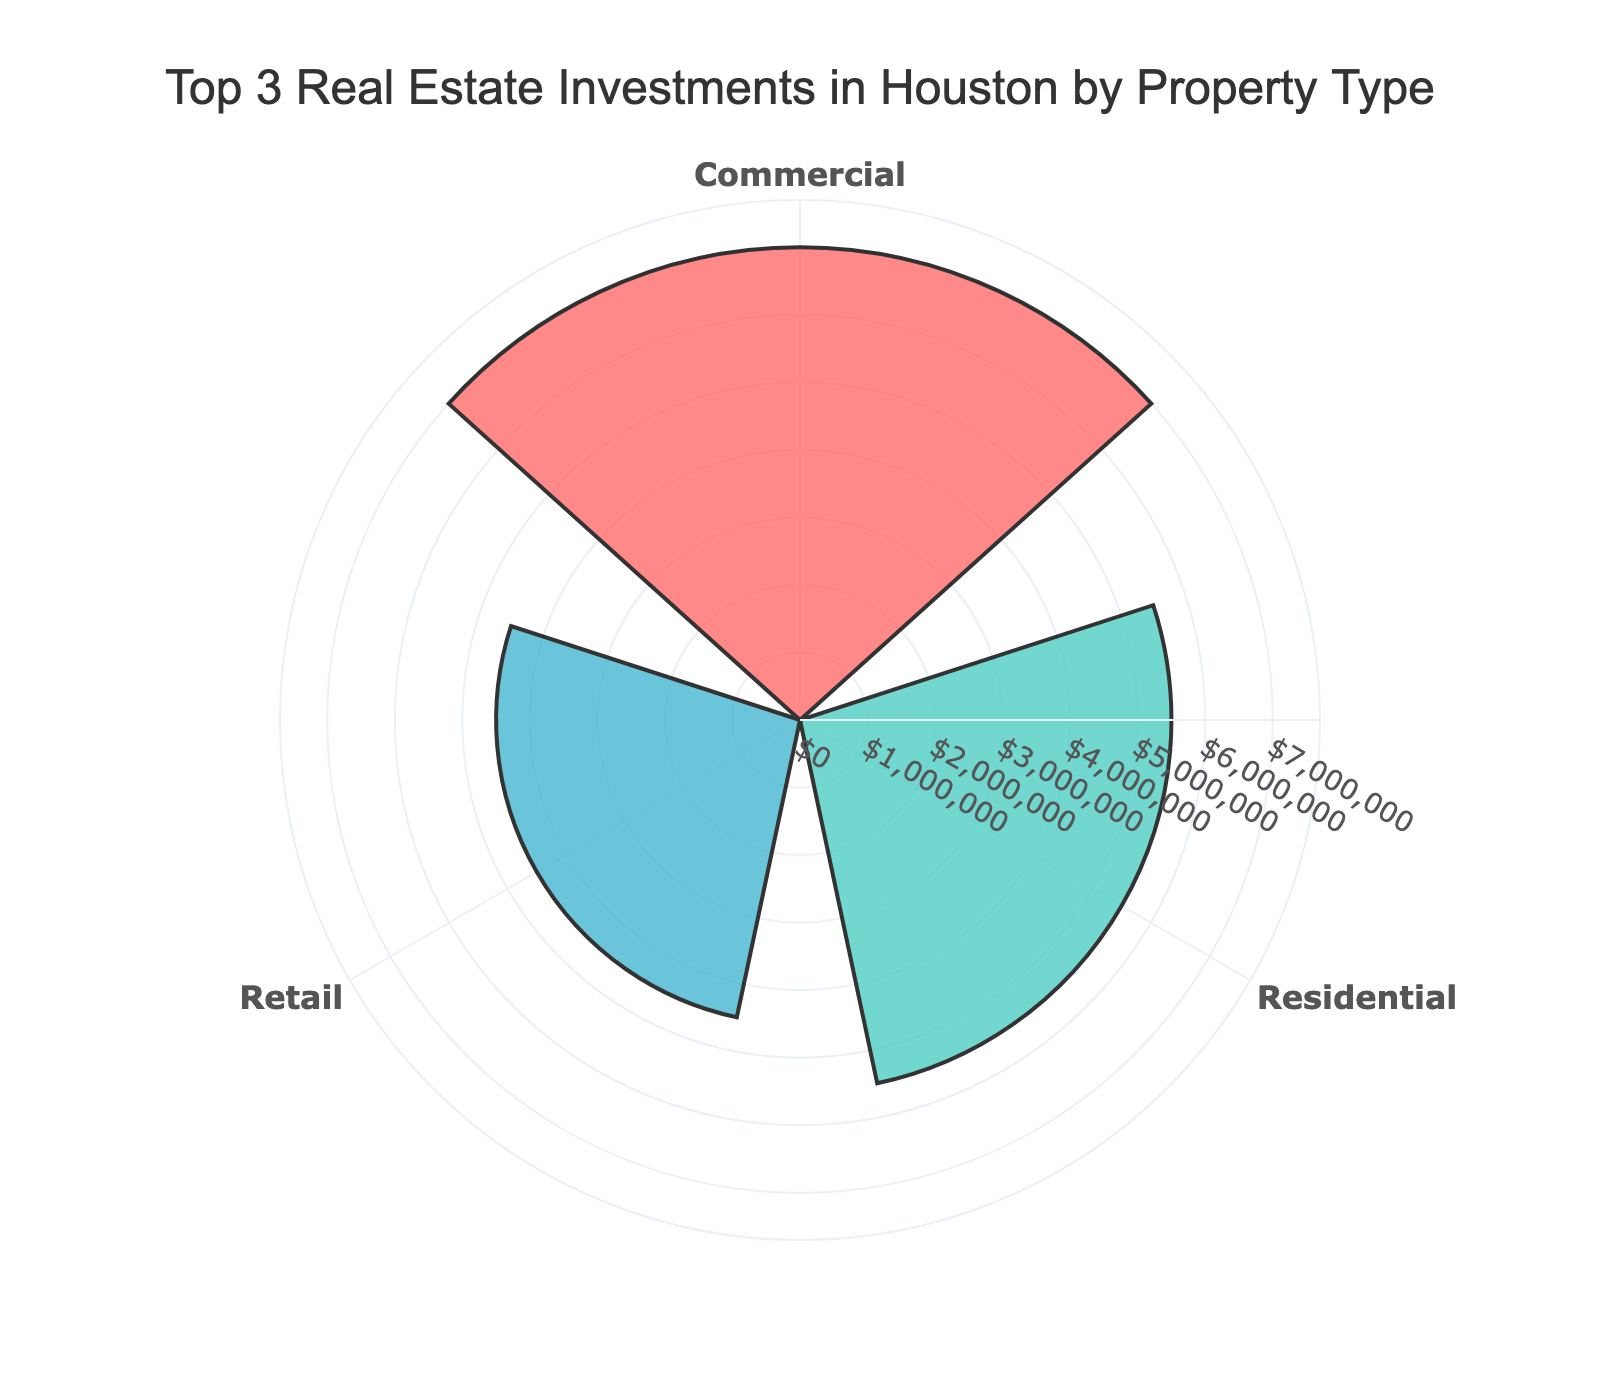what is the title of the chart? The title is usually located at the top of the chart. In this case, it reads "Top 3 Real Estate Investments in Houston by Property Type".
Answer: Top 3 Real Estate Investments in Houston by Property Type How many property types are shown on the chart? By examining the categories shown in the rose chart, we can count three different property types.
Answer: Three Which property type has the largest investment amount? By comparing the lengths of the bars in the rose chart, it's clear that the Commercial property type has the longest bar, indicating the largest investment amount.
Answer: Commercial What are the colors representing each property type? The colors used in the chart are visual cues. The colors are: Residential (red), Commercial (greenish-blue), and Industrial (blue).
Answer: Residential is red, Commercial is greenish-blue, and Industrial is blue what is the total investment amount for Residential and Industrial combined? Adding the investment amounts for Residential ($5,500,000) and Industrial ($3,000,000) gives a total of $8,500,000.
Answer: $8,500,000 What is the difference between the investment amounts in Commercial and Residential property types? The investment amount in Commercial is $7,000,000 and in Residential is $5,500,000. Subtracting these gives a difference of $1,500,000.
Answer: $1,500,000 Which property type has the shortest bar in the chart? Observing the lengths of the bars, the Industrial property type has the shortest bar, indicating the lowest investment amount among the top 3.
Answer: Industrial 